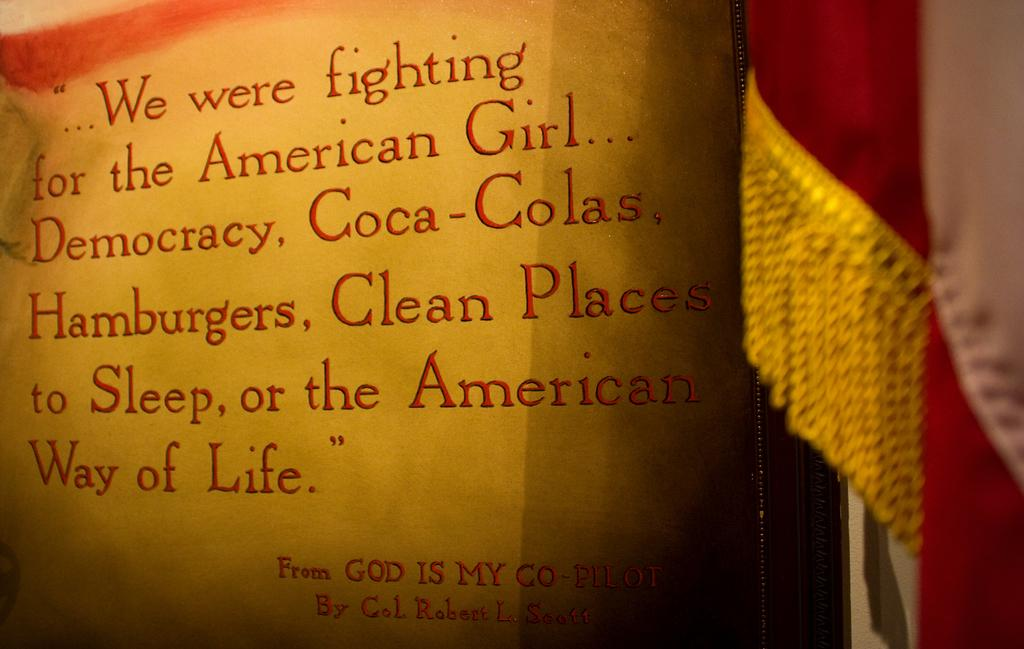<image>
Provide a brief description of the given image. A red text which is a quote taken from God is my co-pilot. 